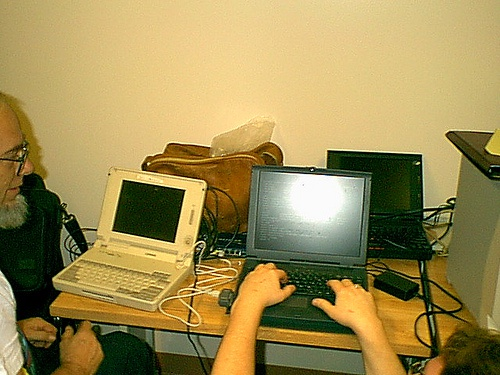Describe the objects in this image and their specific colors. I can see laptop in tan, black, ivory, gray, and darkgray tones, laptop in tan, black, and khaki tones, people in tan, black, and olive tones, laptop in tan, black, and darkgreen tones, and people in tan, black, orange, and gold tones in this image. 